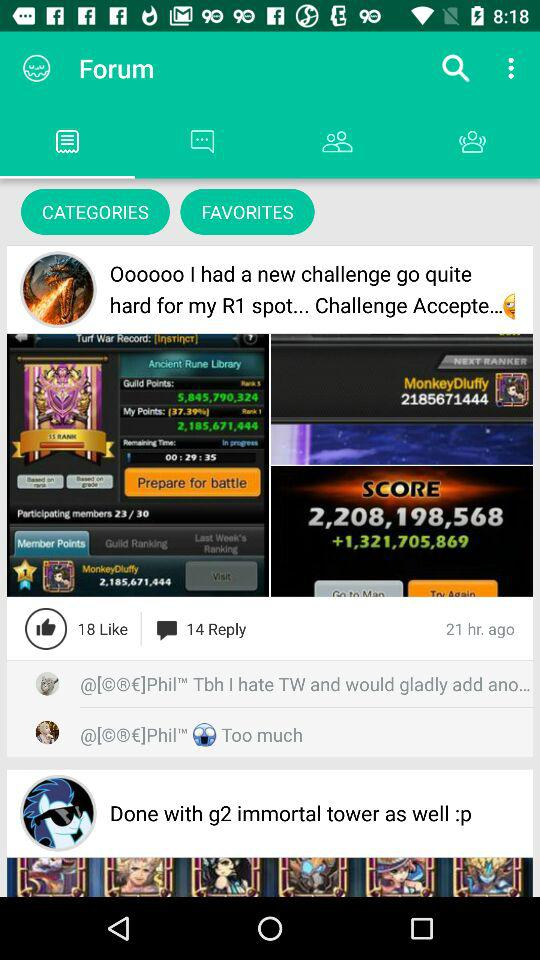How many likes are there? There are 18 likes. 